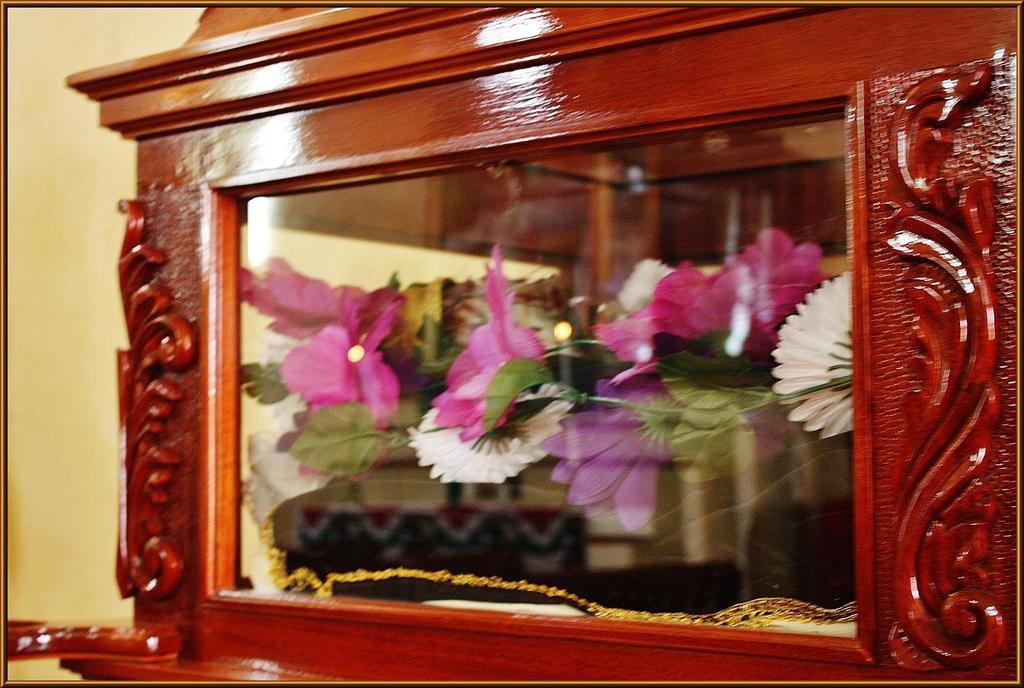What type of furniture is in the image? There is a cupboard in the image. What can be found inside the cupboard? Flowers are present inside the cupboard. What type of juice can be seen being poured by the dinosaurs in the image? There are no dinosaurs or juice present in the image; it only features a cupboard with flowers inside. 